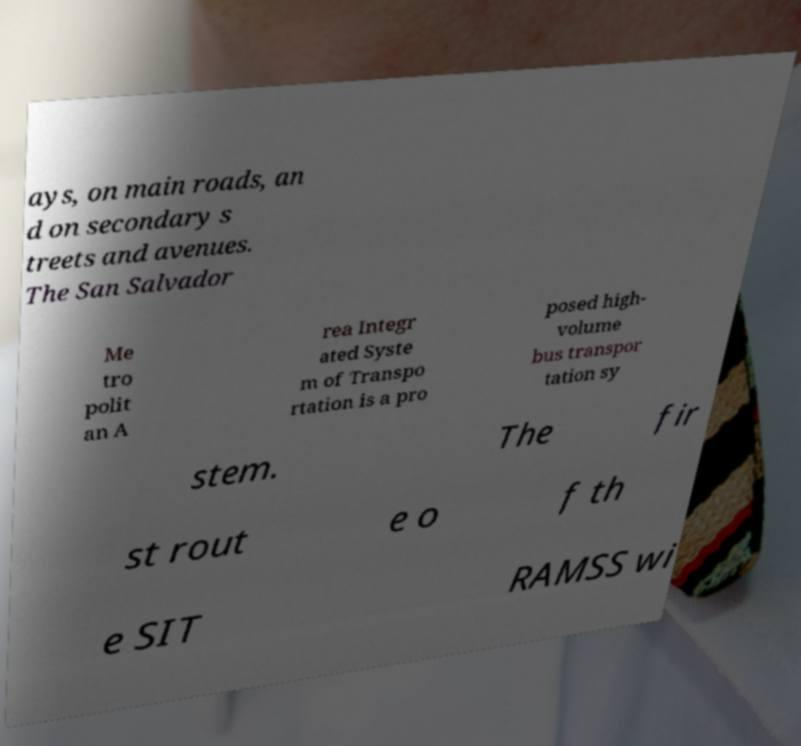Please read and relay the text visible in this image. What does it say? ays, on main roads, an d on secondary s treets and avenues. The San Salvador Me tro polit an A rea Integr ated Syste m of Transpo rtation is a pro posed high- volume bus transpor tation sy stem. The fir st rout e o f th e SIT RAMSS wi 